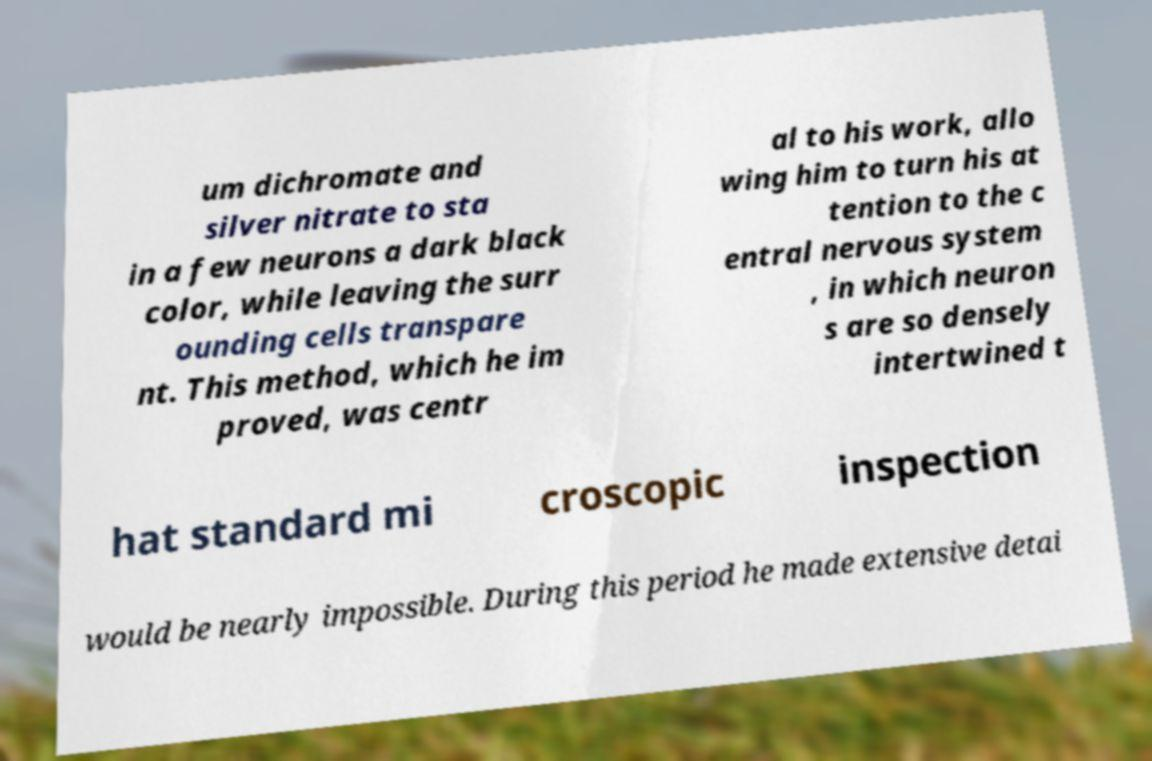I need the written content from this picture converted into text. Can you do that? um dichromate and silver nitrate to sta in a few neurons a dark black color, while leaving the surr ounding cells transpare nt. This method, which he im proved, was centr al to his work, allo wing him to turn his at tention to the c entral nervous system , in which neuron s are so densely intertwined t hat standard mi croscopic inspection would be nearly impossible. During this period he made extensive detai 